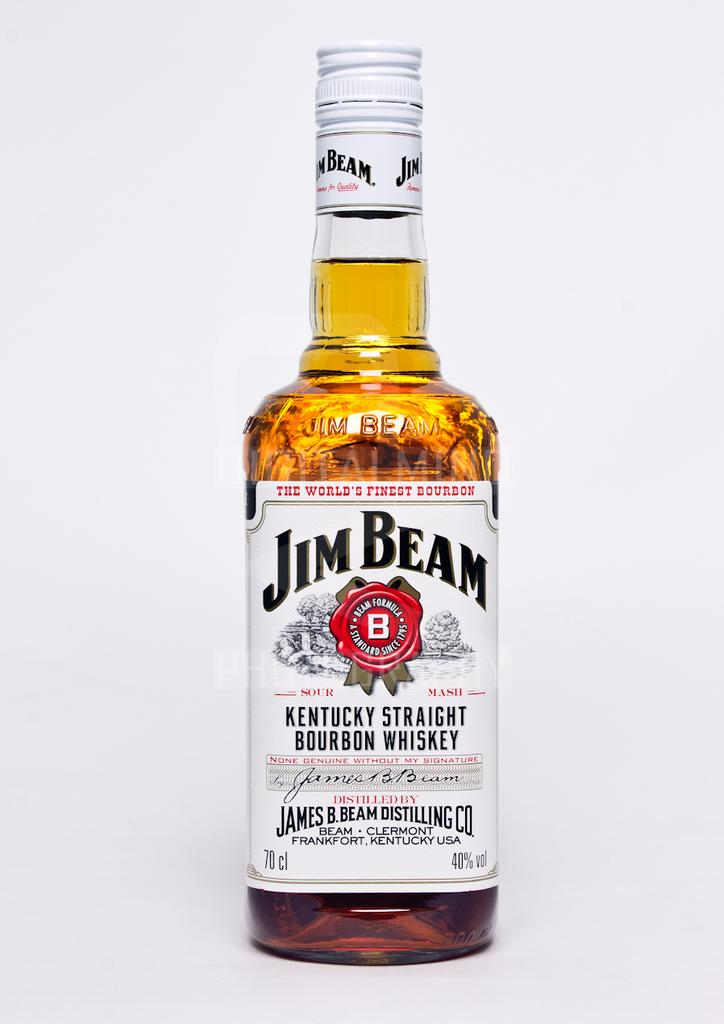<image>
Present a compact description of the photo's key features. A bottle of Jim Beam sits by itself. 